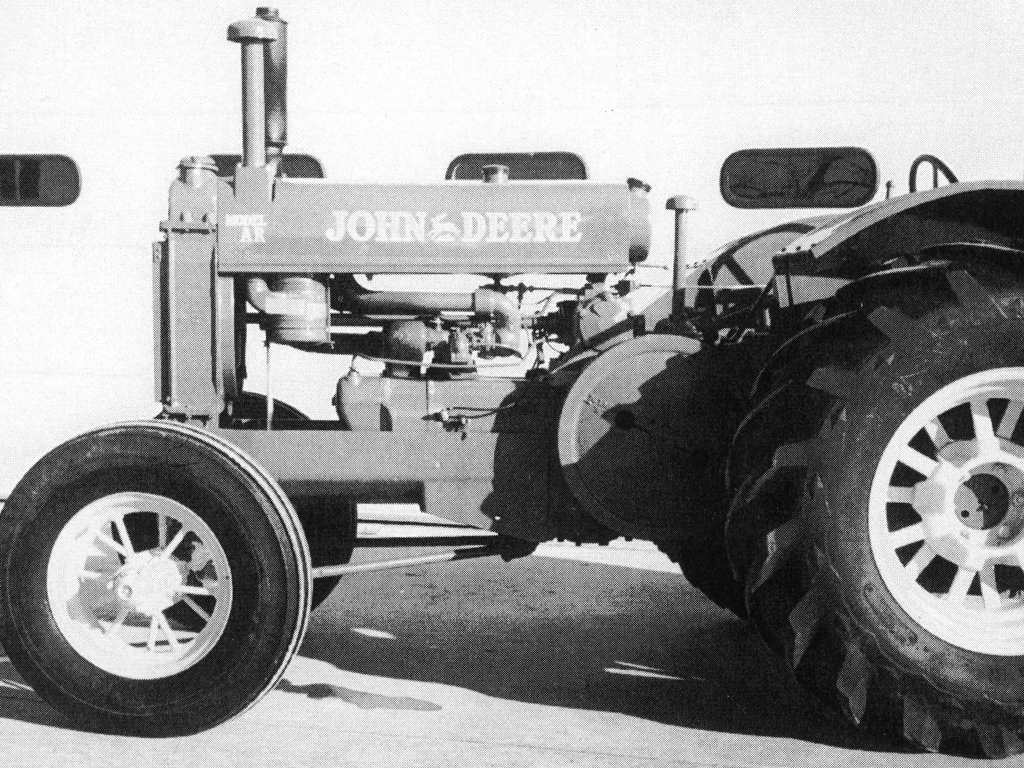Can you tell me more about the tractor's features or its possible era of production? The tractor in the image has a prominent logo which suggests it's a model by a well-known manufacturer. It features large rear wheels with deep treads for traction and smaller front wheels for steering. The engine is exposed, indicating it might be from the mid-20th century, a time when such designs were common. The simple, robust construction hints at a focus on durability and function over comfort and aesthetics. 